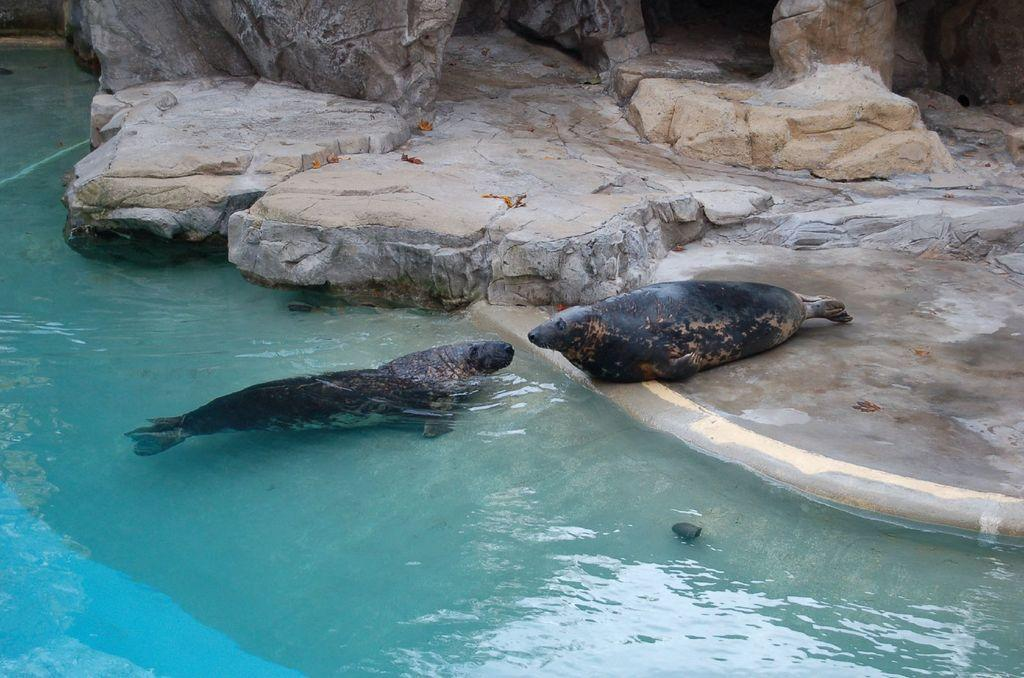What is located on the left side of the image? There is water on the left side of the image. What type of animal can be seen in the water? There is a seal in the water. Where is the other seal located in the image? There is another seal on the land in front of the water. What can be seen in the background of the image? There are rocks in the background of the image. What type of blade is being used by the seal in the image? There is no blade present in the image; it features seals in water and on land, along with rocks in the background. 